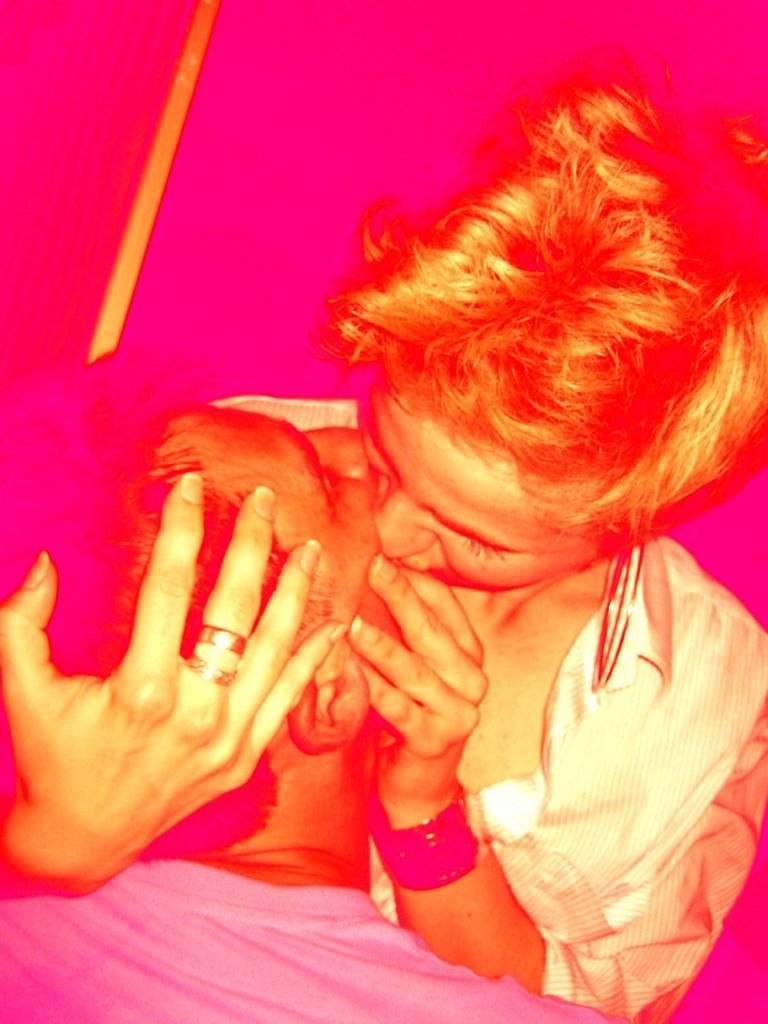Please provide a concise description of this image. In this picture we can see two persons are kissing each other. 